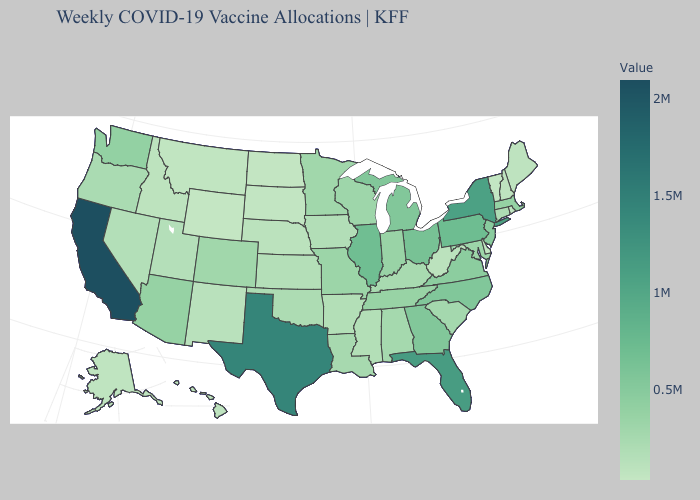Does Maryland have a lower value than Texas?
Write a very short answer. Yes. Does California have the highest value in the USA?
Concise answer only. Yes. Which states have the lowest value in the MidWest?
Quick response, please. North Dakota. Which states have the highest value in the USA?
Quick response, please. California. 